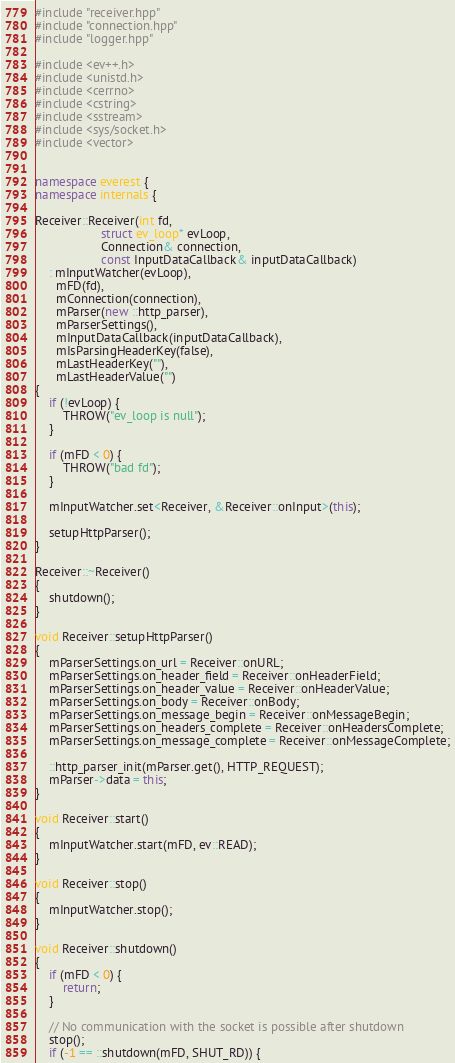Convert code to text. <code><loc_0><loc_0><loc_500><loc_500><_C++_>#include "receiver.hpp"
#include "connection.hpp"
#include "logger.hpp"

#include <ev++.h>
#include <unistd.h>
#include <cerrno>
#include <cstring>
#include <sstream>
#include <sys/socket.h>
#include <vector>


namespace everest {
namespace internals {

Receiver::Receiver(int fd,
                   struct ev_loop* evLoop,
                   Connection& connection,
                   const InputDataCallback& inputDataCallback)
	: mInputWatcher(evLoop),
	  mFD(fd),
	  mConnection(connection),
	  mParser(new ::http_parser),
	  mParserSettings(),
	  mInputDataCallback(inputDataCallback),
	  mIsParsingHeaderKey(false),
	  mLastHeaderKey(""),
	  mLastHeaderValue("")
{
	if (!evLoop) {
		THROW("ev_loop is null");
	}

	if (mFD < 0) {
		THROW("bad fd");
	}

	mInputWatcher.set<Receiver, &Receiver::onInput>(this);

	setupHttpParser();
}

Receiver::~Receiver()
{
	shutdown();
}

void Receiver::setupHttpParser()
{
	mParserSettings.on_url = Receiver::onURL;
	mParserSettings.on_header_field = Receiver::onHeaderField;
	mParserSettings.on_header_value = Receiver::onHeaderValue;
	mParserSettings.on_body = Receiver::onBody;
	mParserSettings.on_message_begin = Receiver::onMessageBegin;
	mParserSettings.on_headers_complete = Receiver::onHeadersComplete;
	mParserSettings.on_message_complete = Receiver::onMessageComplete;

	::http_parser_init(mParser.get(), HTTP_REQUEST);
	mParser->data = this;
}

void Receiver::start()
{
	mInputWatcher.start(mFD, ev::READ);
}

void Receiver::stop()
{
	mInputWatcher.stop();
}

void Receiver::shutdown()
{
	if (mFD < 0) {
		return;
	}

	// No communication with the socket is possible after shutdown
	stop();
	if (-1 == ::shutdown(mFD, SHUT_RD)) {</code> 